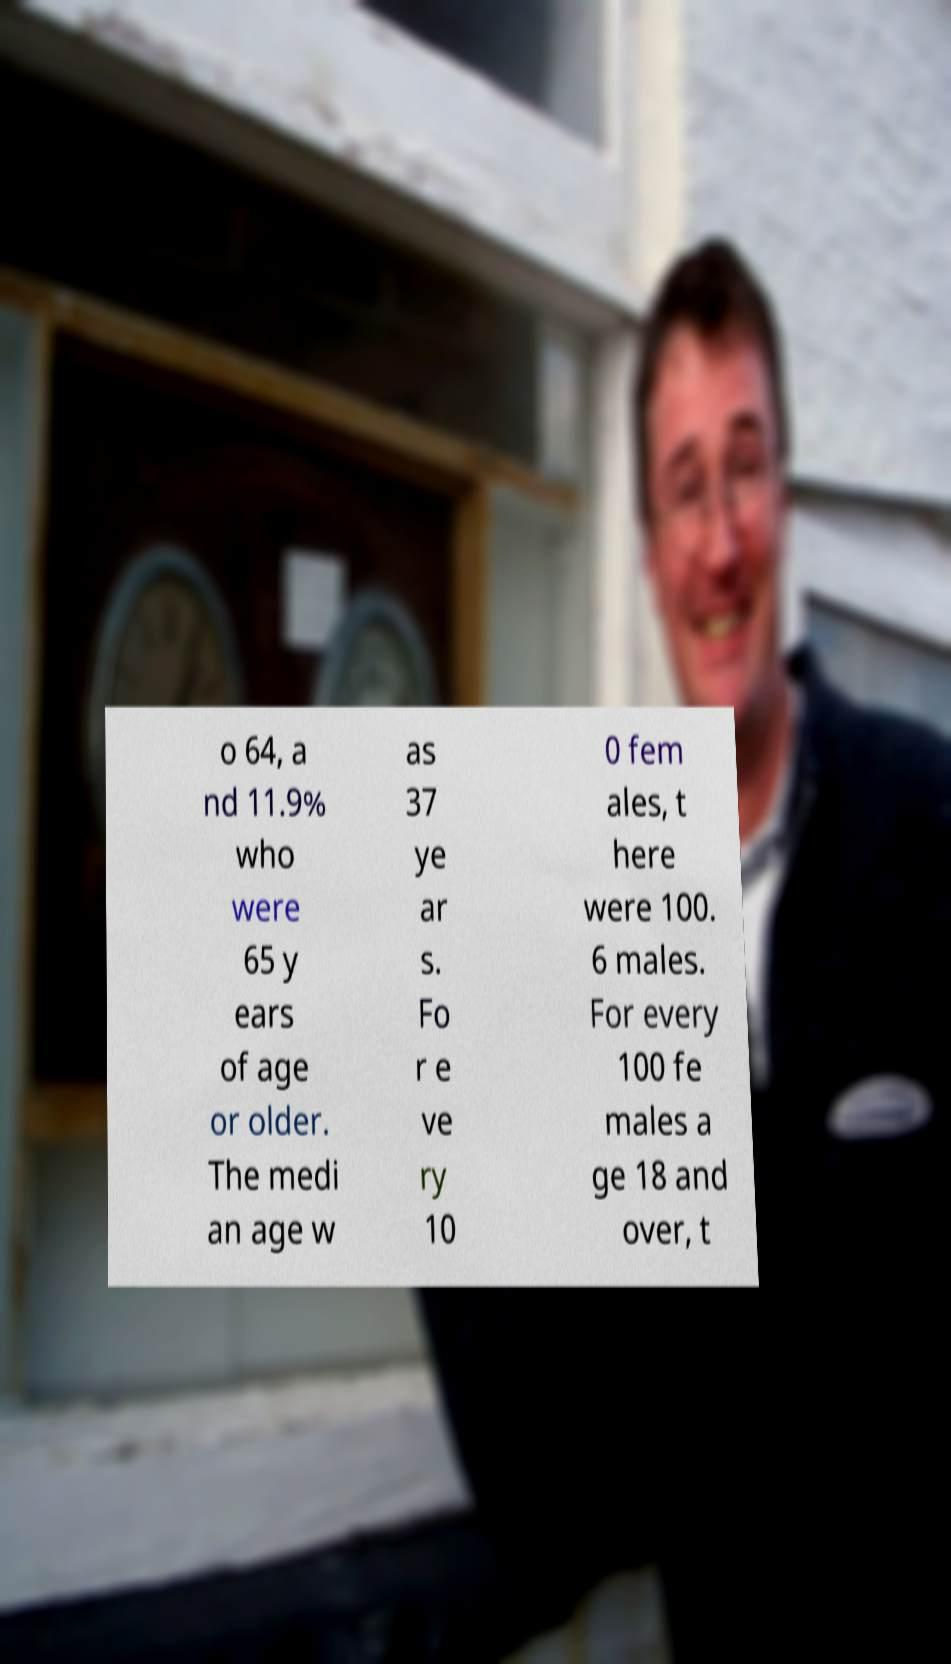Please identify and transcribe the text found in this image. o 64, a nd 11.9% who were 65 y ears of age or older. The medi an age w as 37 ye ar s. Fo r e ve ry 10 0 fem ales, t here were 100. 6 males. For every 100 fe males a ge 18 and over, t 